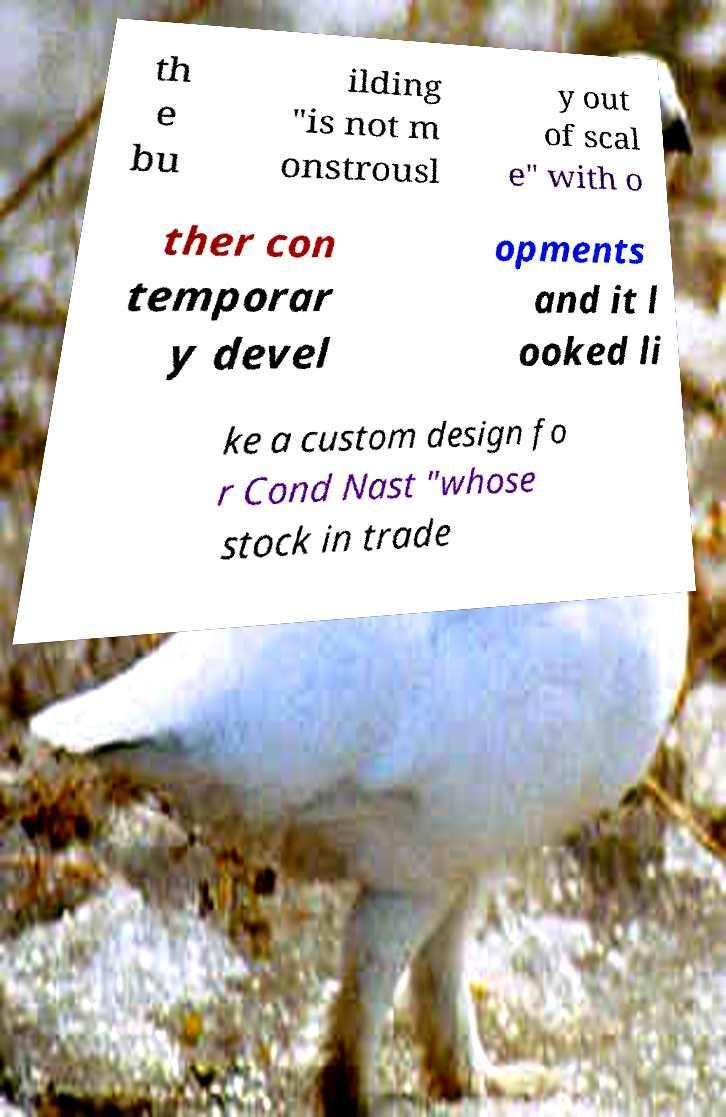Could you extract and type out the text from this image? th e bu ilding "is not m onstrousl y out of scal e" with o ther con temporar y devel opments and it l ooked li ke a custom design fo r Cond Nast "whose stock in trade 